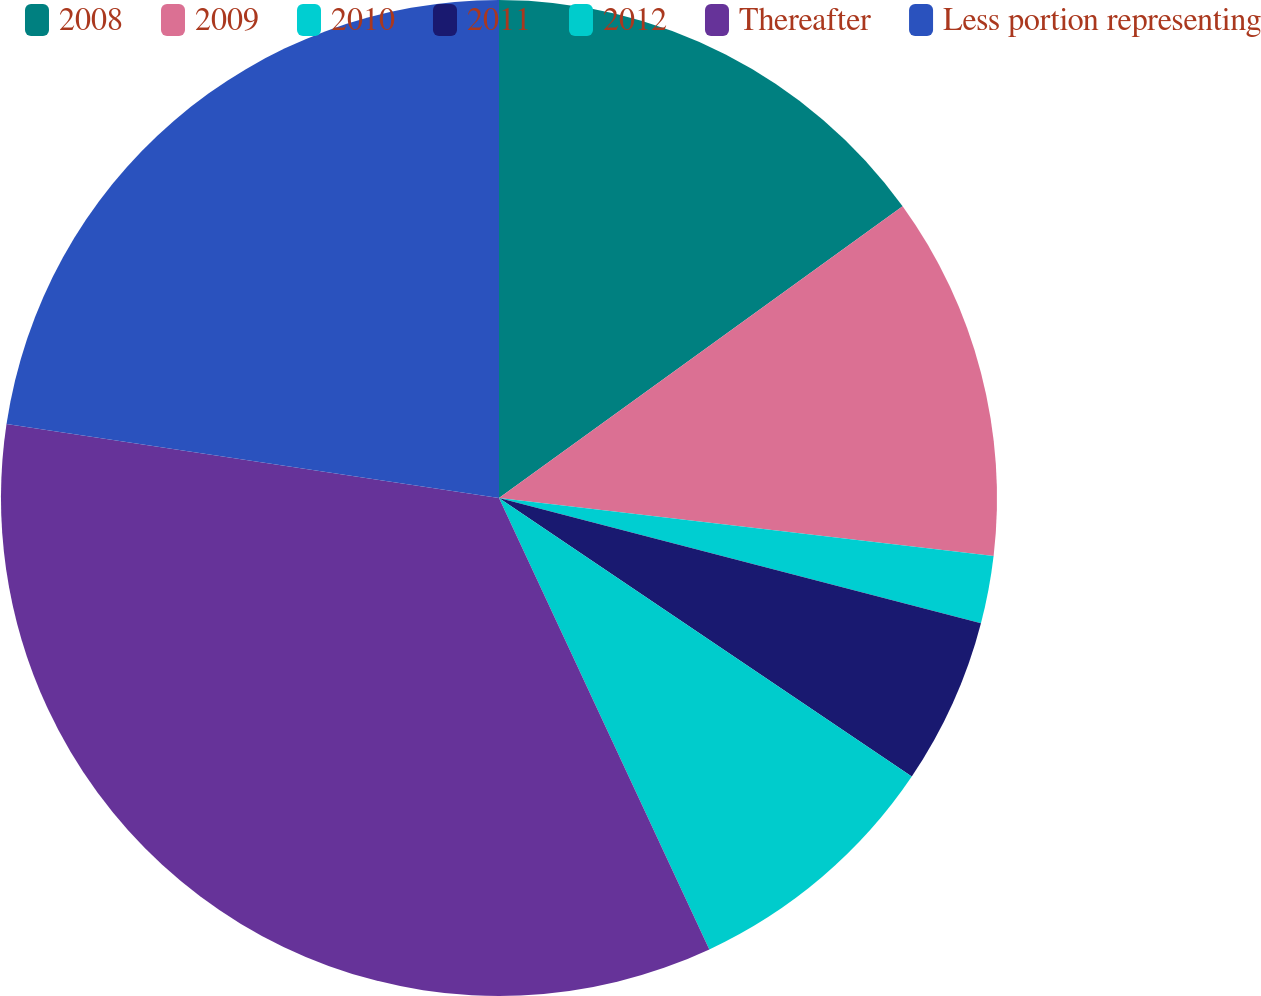Convert chart to OTSL. <chart><loc_0><loc_0><loc_500><loc_500><pie_chart><fcel>2008<fcel>2009<fcel>2010<fcel>2011<fcel>2012<fcel>Thereafter<fcel>Less portion representing<nl><fcel>15.04%<fcel>11.82%<fcel>2.19%<fcel>5.4%<fcel>8.61%<fcel>34.31%<fcel>22.63%<nl></chart> 